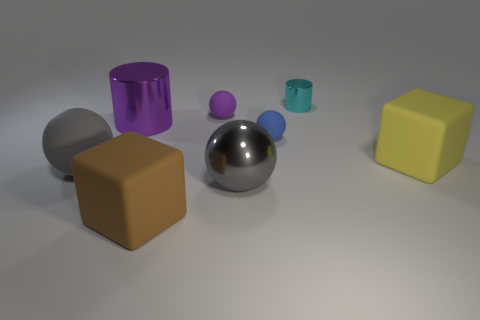How many gray spheres must be subtracted to get 1 gray spheres? 1 Add 1 large red metallic cylinders. How many objects exist? 9 Subtract all cubes. How many objects are left? 6 Subtract all tiny cyan metallic spheres. Subtract all small spheres. How many objects are left? 6 Add 3 purple metallic cylinders. How many purple metallic cylinders are left? 4 Add 4 tiny purple rubber things. How many tiny purple rubber things exist? 5 Subtract 0 cyan balls. How many objects are left? 8 